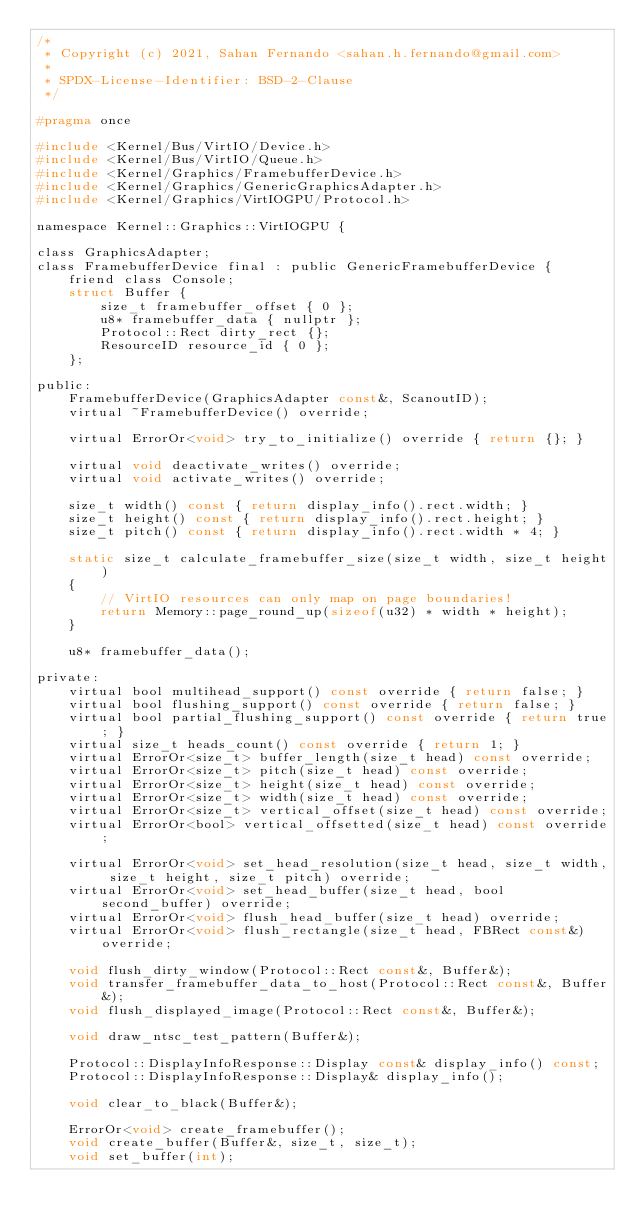Convert code to text. <code><loc_0><loc_0><loc_500><loc_500><_C_>/*
 * Copyright (c) 2021, Sahan Fernando <sahan.h.fernando@gmail.com>
 *
 * SPDX-License-Identifier: BSD-2-Clause
 */

#pragma once

#include <Kernel/Bus/VirtIO/Device.h>
#include <Kernel/Bus/VirtIO/Queue.h>
#include <Kernel/Graphics/FramebufferDevice.h>
#include <Kernel/Graphics/GenericGraphicsAdapter.h>
#include <Kernel/Graphics/VirtIOGPU/Protocol.h>

namespace Kernel::Graphics::VirtIOGPU {

class GraphicsAdapter;
class FramebufferDevice final : public GenericFramebufferDevice {
    friend class Console;
    struct Buffer {
        size_t framebuffer_offset { 0 };
        u8* framebuffer_data { nullptr };
        Protocol::Rect dirty_rect {};
        ResourceID resource_id { 0 };
    };

public:
    FramebufferDevice(GraphicsAdapter const&, ScanoutID);
    virtual ~FramebufferDevice() override;

    virtual ErrorOr<void> try_to_initialize() override { return {}; }

    virtual void deactivate_writes() override;
    virtual void activate_writes() override;

    size_t width() const { return display_info().rect.width; }
    size_t height() const { return display_info().rect.height; }
    size_t pitch() const { return display_info().rect.width * 4; }

    static size_t calculate_framebuffer_size(size_t width, size_t height)
    {
        // VirtIO resources can only map on page boundaries!
        return Memory::page_round_up(sizeof(u32) * width * height);
    }

    u8* framebuffer_data();

private:
    virtual bool multihead_support() const override { return false; }
    virtual bool flushing_support() const override { return false; }
    virtual bool partial_flushing_support() const override { return true; }
    virtual size_t heads_count() const override { return 1; }
    virtual ErrorOr<size_t> buffer_length(size_t head) const override;
    virtual ErrorOr<size_t> pitch(size_t head) const override;
    virtual ErrorOr<size_t> height(size_t head) const override;
    virtual ErrorOr<size_t> width(size_t head) const override;
    virtual ErrorOr<size_t> vertical_offset(size_t head) const override;
    virtual ErrorOr<bool> vertical_offsetted(size_t head) const override;

    virtual ErrorOr<void> set_head_resolution(size_t head, size_t width, size_t height, size_t pitch) override;
    virtual ErrorOr<void> set_head_buffer(size_t head, bool second_buffer) override;
    virtual ErrorOr<void> flush_head_buffer(size_t head) override;
    virtual ErrorOr<void> flush_rectangle(size_t head, FBRect const&) override;

    void flush_dirty_window(Protocol::Rect const&, Buffer&);
    void transfer_framebuffer_data_to_host(Protocol::Rect const&, Buffer&);
    void flush_displayed_image(Protocol::Rect const&, Buffer&);

    void draw_ntsc_test_pattern(Buffer&);

    Protocol::DisplayInfoResponse::Display const& display_info() const;
    Protocol::DisplayInfoResponse::Display& display_info();

    void clear_to_black(Buffer&);

    ErrorOr<void> create_framebuffer();
    void create_buffer(Buffer&, size_t, size_t);
    void set_buffer(int);
</code> 